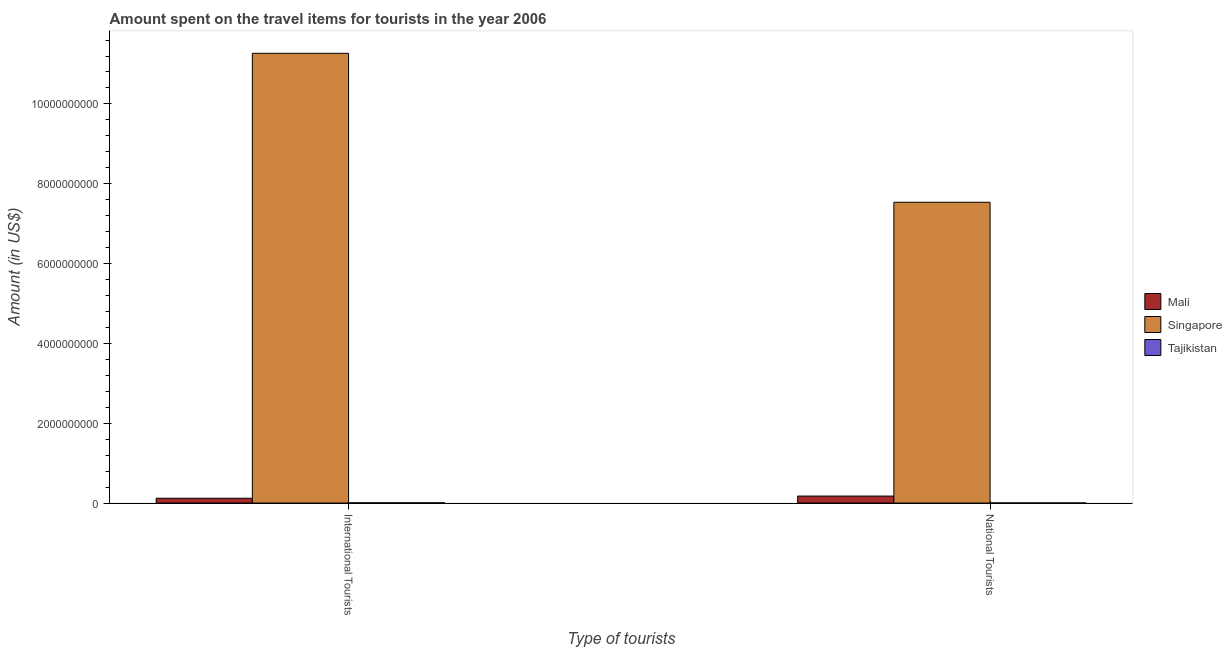How many groups of bars are there?
Your answer should be very brief. 2. Are the number of bars on each tick of the X-axis equal?
Make the answer very short. Yes. How many bars are there on the 1st tick from the left?
Offer a terse response. 3. How many bars are there on the 2nd tick from the right?
Your response must be concise. 3. What is the label of the 2nd group of bars from the left?
Make the answer very short. National Tourists. What is the amount spent on travel items of national tourists in Mali?
Give a very brief answer. 1.75e+08. Across all countries, what is the maximum amount spent on travel items of national tourists?
Your answer should be very brief. 7.54e+09. Across all countries, what is the minimum amount spent on travel items of national tourists?
Ensure brevity in your answer.  2.10e+06. In which country was the amount spent on travel items of national tourists maximum?
Make the answer very short. Singapore. In which country was the amount spent on travel items of national tourists minimum?
Offer a very short reply. Tajikistan. What is the total amount spent on travel items of national tourists in the graph?
Make the answer very short. 7.71e+09. What is the difference between the amount spent on travel items of national tourists in Singapore and that in Mali?
Make the answer very short. 7.36e+09. What is the difference between the amount spent on travel items of international tourists in Singapore and the amount spent on travel items of national tourists in Mali?
Give a very brief answer. 1.11e+1. What is the average amount spent on travel items of international tourists per country?
Keep it short and to the point. 3.80e+09. What is the difference between the amount spent on travel items of international tourists and amount spent on travel items of national tourists in Singapore?
Provide a succinct answer. 3.73e+09. What is the ratio of the amount spent on travel items of international tourists in Tajikistan to that in Singapore?
Your response must be concise. 0. Is the amount spent on travel items of national tourists in Tajikistan less than that in Singapore?
Your response must be concise. Yes. What does the 3rd bar from the left in National Tourists represents?
Give a very brief answer. Tajikistan. What does the 2nd bar from the right in National Tourists represents?
Keep it short and to the point. Singapore. Are all the bars in the graph horizontal?
Give a very brief answer. No. What is the difference between two consecutive major ticks on the Y-axis?
Your answer should be compact. 2.00e+09. What is the title of the graph?
Provide a short and direct response. Amount spent on the travel items for tourists in the year 2006. Does "Nicaragua" appear as one of the legend labels in the graph?
Your response must be concise. No. What is the label or title of the X-axis?
Provide a succinct answer. Type of tourists. What is the label or title of the Y-axis?
Offer a very short reply. Amount (in US$). What is the Amount (in US$) in Mali in International Tourists?
Give a very brief answer. 1.20e+08. What is the Amount (in US$) of Singapore in International Tourists?
Your response must be concise. 1.13e+1. What is the Amount (in US$) in Tajikistan in International Tourists?
Offer a terse response. 6.00e+06. What is the Amount (in US$) in Mali in National Tourists?
Provide a succinct answer. 1.75e+08. What is the Amount (in US$) in Singapore in National Tourists?
Give a very brief answer. 7.54e+09. What is the Amount (in US$) of Tajikistan in National Tourists?
Keep it short and to the point. 2.10e+06. Across all Type of tourists, what is the maximum Amount (in US$) in Mali?
Your answer should be very brief. 1.75e+08. Across all Type of tourists, what is the maximum Amount (in US$) of Singapore?
Your answer should be very brief. 1.13e+1. Across all Type of tourists, what is the minimum Amount (in US$) of Mali?
Your answer should be compact. 1.20e+08. Across all Type of tourists, what is the minimum Amount (in US$) in Singapore?
Provide a short and direct response. 7.54e+09. Across all Type of tourists, what is the minimum Amount (in US$) of Tajikistan?
Your response must be concise. 2.10e+06. What is the total Amount (in US$) of Mali in the graph?
Your answer should be very brief. 2.95e+08. What is the total Amount (in US$) in Singapore in the graph?
Provide a succinct answer. 1.88e+1. What is the total Amount (in US$) of Tajikistan in the graph?
Your response must be concise. 8.10e+06. What is the difference between the Amount (in US$) of Mali in International Tourists and that in National Tourists?
Provide a succinct answer. -5.50e+07. What is the difference between the Amount (in US$) in Singapore in International Tourists and that in National Tourists?
Give a very brief answer. 3.73e+09. What is the difference between the Amount (in US$) in Tajikistan in International Tourists and that in National Tourists?
Offer a terse response. 3.90e+06. What is the difference between the Amount (in US$) in Mali in International Tourists and the Amount (in US$) in Singapore in National Tourists?
Keep it short and to the point. -7.42e+09. What is the difference between the Amount (in US$) of Mali in International Tourists and the Amount (in US$) of Tajikistan in National Tourists?
Give a very brief answer. 1.18e+08. What is the difference between the Amount (in US$) in Singapore in International Tourists and the Amount (in US$) in Tajikistan in National Tourists?
Give a very brief answer. 1.13e+1. What is the average Amount (in US$) of Mali per Type of tourists?
Provide a succinct answer. 1.48e+08. What is the average Amount (in US$) in Singapore per Type of tourists?
Give a very brief answer. 9.40e+09. What is the average Amount (in US$) of Tajikistan per Type of tourists?
Provide a short and direct response. 4.05e+06. What is the difference between the Amount (in US$) of Mali and Amount (in US$) of Singapore in International Tourists?
Keep it short and to the point. -1.11e+1. What is the difference between the Amount (in US$) in Mali and Amount (in US$) in Tajikistan in International Tourists?
Offer a terse response. 1.14e+08. What is the difference between the Amount (in US$) in Singapore and Amount (in US$) in Tajikistan in International Tourists?
Make the answer very short. 1.13e+1. What is the difference between the Amount (in US$) in Mali and Amount (in US$) in Singapore in National Tourists?
Give a very brief answer. -7.36e+09. What is the difference between the Amount (in US$) of Mali and Amount (in US$) of Tajikistan in National Tourists?
Provide a short and direct response. 1.73e+08. What is the difference between the Amount (in US$) of Singapore and Amount (in US$) of Tajikistan in National Tourists?
Give a very brief answer. 7.53e+09. What is the ratio of the Amount (in US$) in Mali in International Tourists to that in National Tourists?
Give a very brief answer. 0.69. What is the ratio of the Amount (in US$) in Singapore in International Tourists to that in National Tourists?
Your answer should be very brief. 1.5. What is the ratio of the Amount (in US$) in Tajikistan in International Tourists to that in National Tourists?
Your answer should be compact. 2.86. What is the difference between the highest and the second highest Amount (in US$) in Mali?
Ensure brevity in your answer.  5.50e+07. What is the difference between the highest and the second highest Amount (in US$) in Singapore?
Make the answer very short. 3.73e+09. What is the difference between the highest and the second highest Amount (in US$) in Tajikistan?
Ensure brevity in your answer.  3.90e+06. What is the difference between the highest and the lowest Amount (in US$) in Mali?
Ensure brevity in your answer.  5.50e+07. What is the difference between the highest and the lowest Amount (in US$) of Singapore?
Provide a succinct answer. 3.73e+09. What is the difference between the highest and the lowest Amount (in US$) of Tajikistan?
Provide a short and direct response. 3.90e+06. 